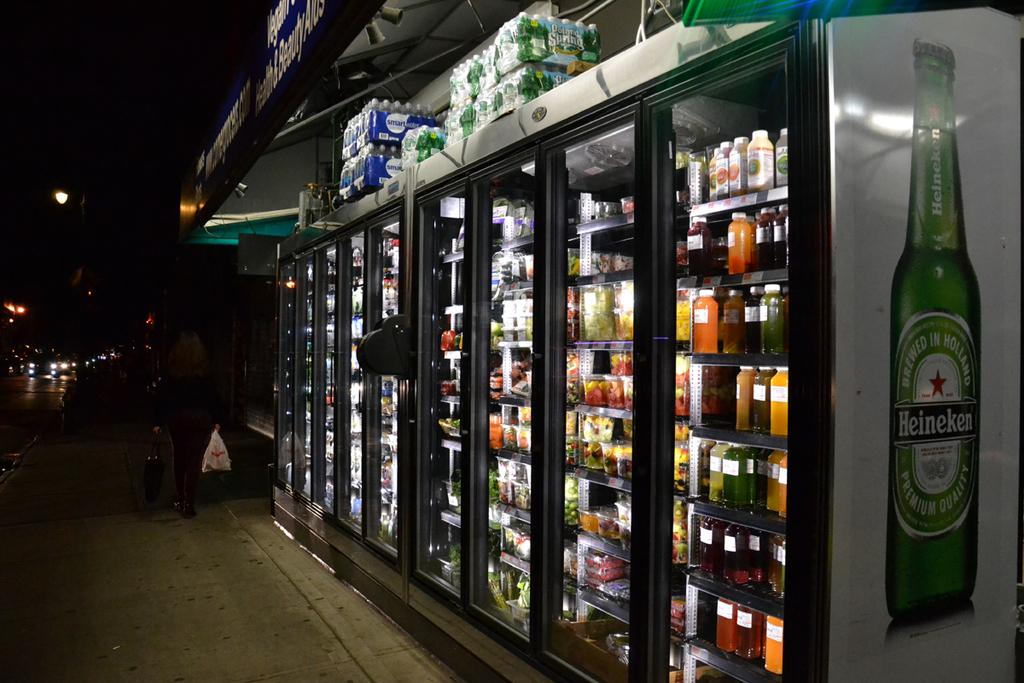Provide a one-sentence caption for the provided image. A Heineken bottle is displayed on the side of some supermarket fridges. 